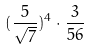<formula> <loc_0><loc_0><loc_500><loc_500>( \frac { 5 } { \sqrt { 7 } } ) ^ { 4 } \cdot \frac { 3 } { 5 6 }</formula> 